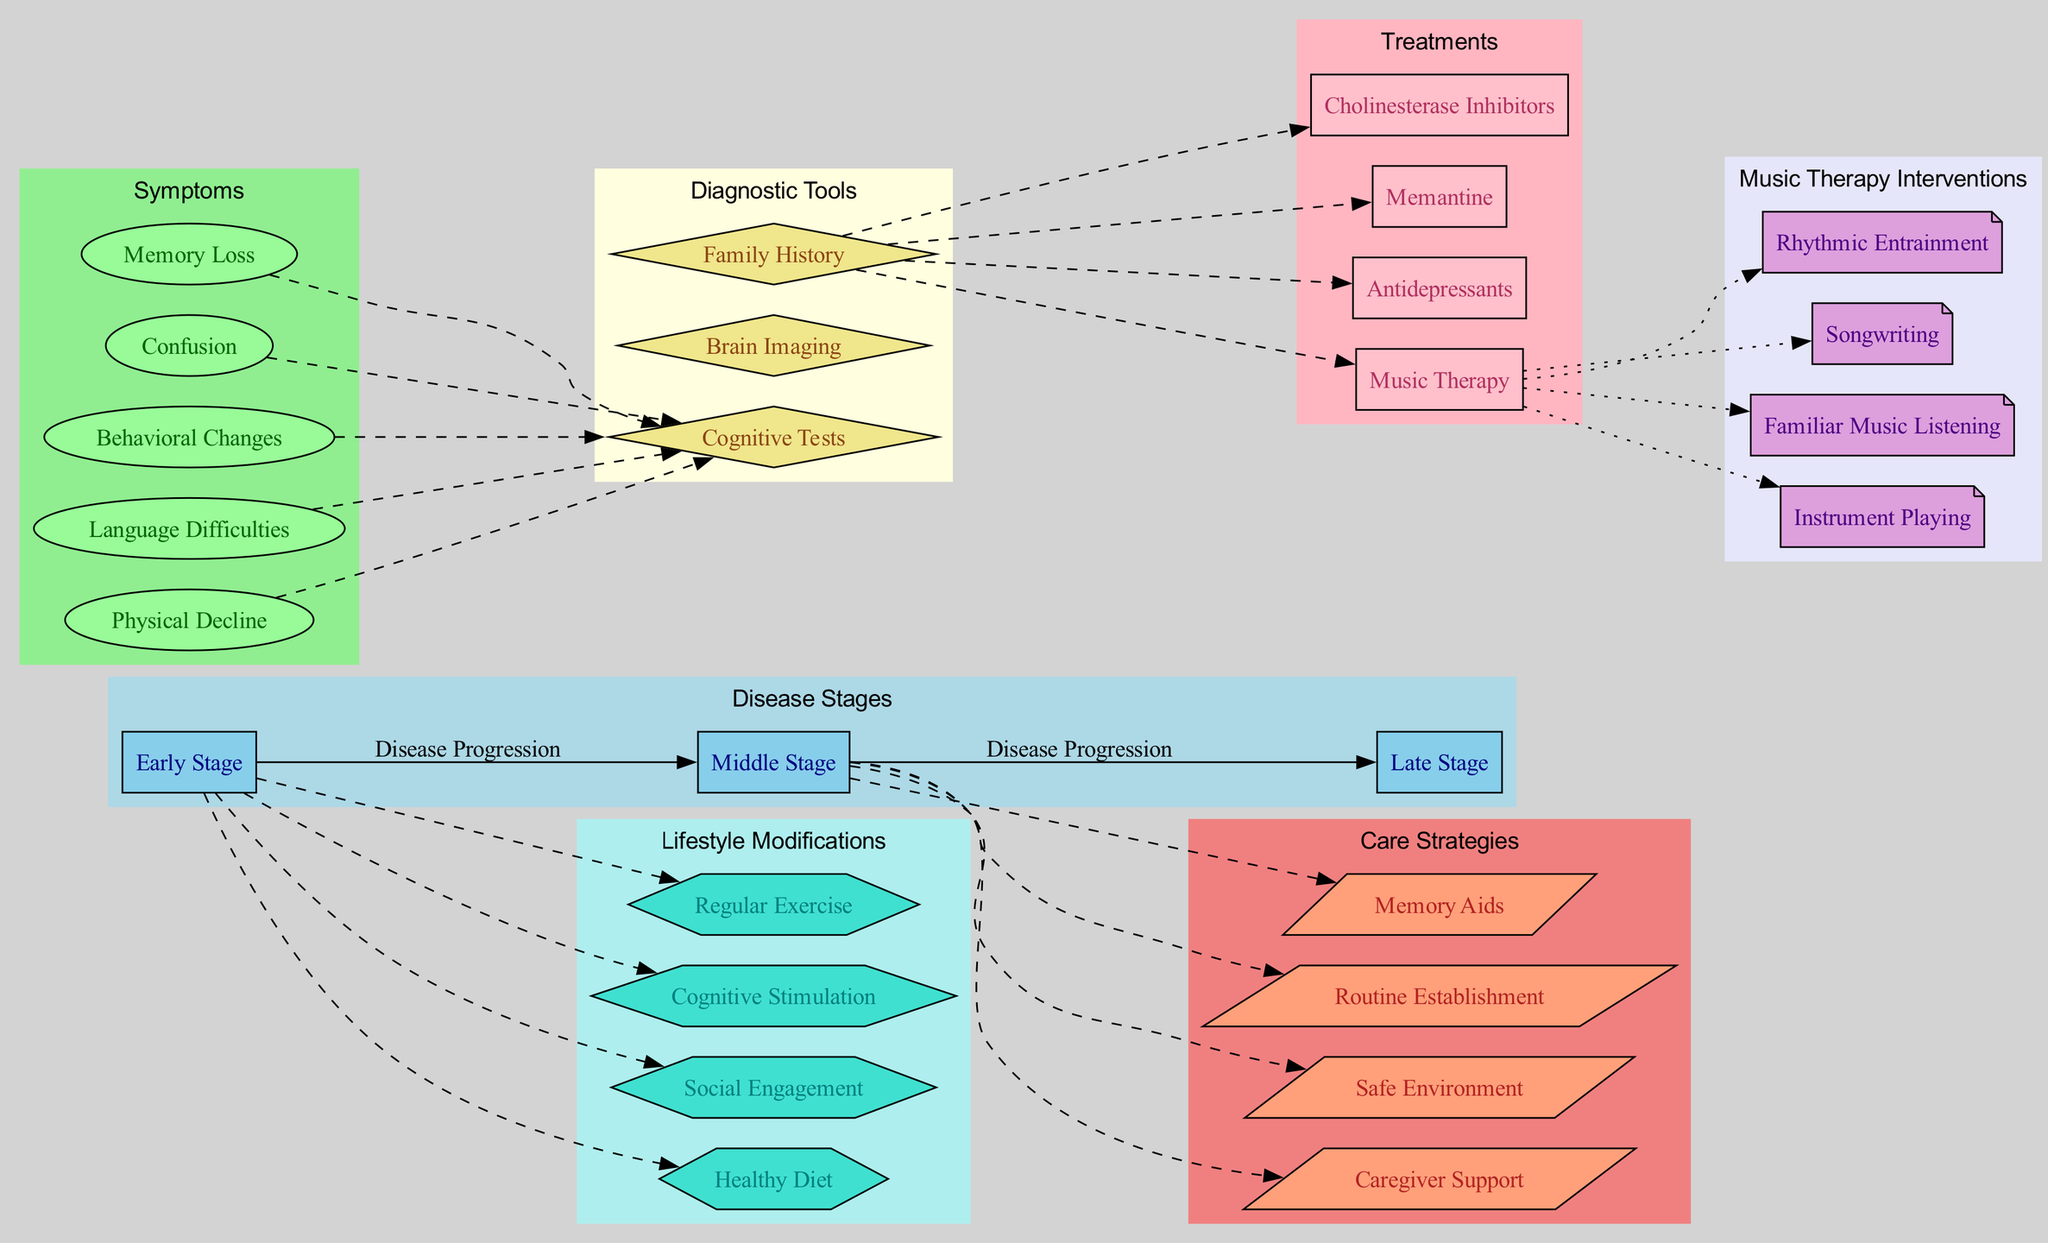What are the three stages of Alzheimer's Disease presented in the diagram? The diagram lists the stages under the 'Disease Stages' cluster, which consists of 'Early Stage', 'Middle Stage', and 'Late Stage'.
Answer: Early Stage, Middle Stage, Late Stage How many symptoms are listed in the diagram? By reviewing the 'Symptoms' cluster in the diagram, we can see that there are five symptoms mentioned: 'Memory Loss', 'Confusion', 'Behavioral Changes', 'Language Difficulties', and 'Physical Decline'.
Answer: 5 Which treatment is specifically associated with music therapy in the diagram? Under the 'Treatments' cluster, one of the treatments listed is 'Music Therapy'. This treatment is also associated with multiple specific interventions shown in the music therapy interventions cluster.
Answer: Music Therapy What are the care strategies suggested for the Middle Stage of the disease? Examining the connections made in the diagram, we see that the Middle Stage links to four care strategies: 'Memory Aids', 'Routine Establishment', 'Safe Environment', and 'Caregiver Support'.
Answer: Memory Aids, Routine Establishment, Safe Environment, Caregiver Support How do 'Familiar Music Listening' and 'Instrument Playing' relate to the treatments? The diagram shows that both 'Familiar Music Listening' and 'Instrument Playing' are connected to the treatment 'Music Therapy', indicating they are specific interventions used within this treatment.
Answer: Music Therapy Which diagnostic tool connects most directly to the treatment options? In the diagram, 'Brain Imaging' acts as the last diagnostic tool listed, which connects to all the treatment options, including 'Cholinesterase Inhibitors', 'Memantine', 'Antidepressants', and 'Music Therapy'.
Answer: Brain Imaging What lifestyle modification is related to cognitive stimulation? Looking at the 'Lifestyle Modifications' cluster, 'Cognitive Stimulation' is present; it demonstrates an effort to promote cognitive health alongside other modifications such as 'Regular Exercise' and 'Social Engagement'.
Answer: Cognitive Stimulation Which music therapy interventions are part of the diagram? The 'Music Therapy Interventions' cluster displays four interventions: 'Rhythmic Entrainment', 'Songwriting', 'Familiar Music Listening', and 'Instrument Playing'.
Answer: Rhythmic Entrainment, Songwriting, Familiar Music Listening, Instrument Playing What connections are shown between the Late Stage and additional care strategies? The diagram does not indicate direct connections from the Late Stage to other care strategies, as it primarily shows the connections for the Middle Stage. Thus, this stage does not link to new strategies uniquely.
Answer: None 